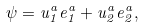<formula> <loc_0><loc_0><loc_500><loc_500>\psi = u _ { 1 } ^ { a } e _ { 1 } ^ { a } + u _ { 2 } ^ { a } e _ { 2 } ^ { a } ,</formula> 